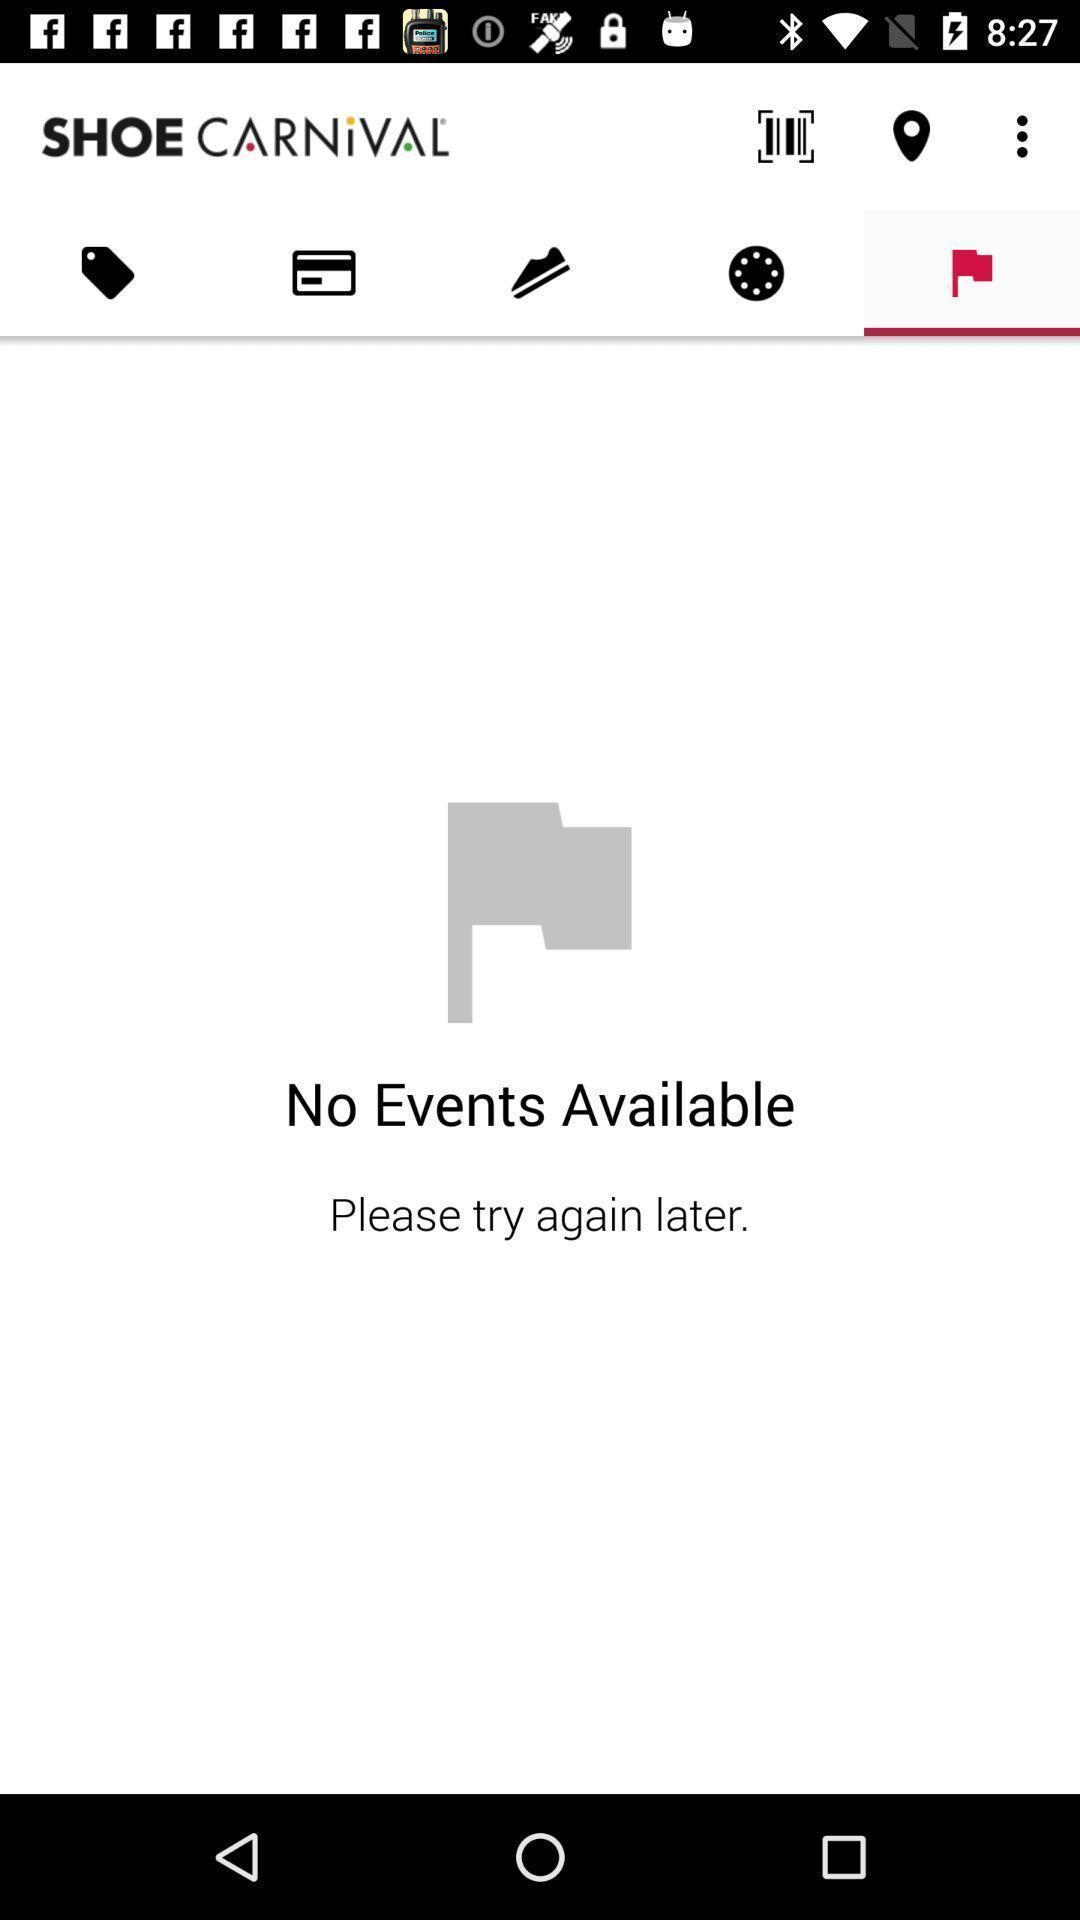Explain what's happening in this screen capture. Page displaying the shoe carnival in app. 